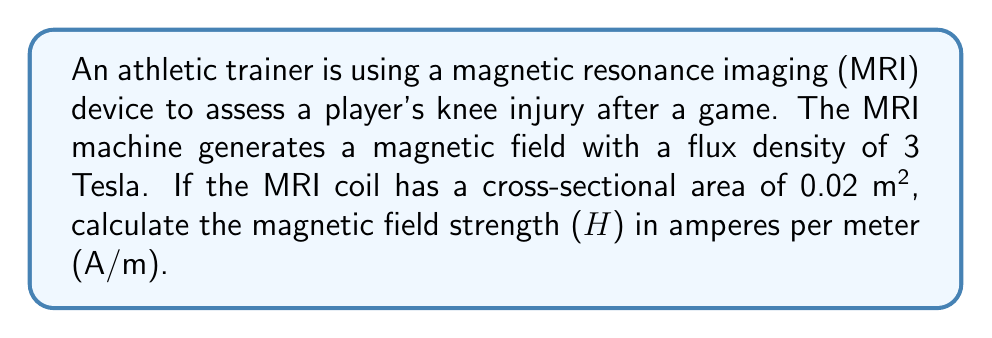Could you help me with this problem? To solve this problem, we'll follow these steps:

1. Recall the relationship between magnetic flux density (B), magnetic field strength (H), and permeability (μ):

   $$B = \mu H$$

2. In this case, we're dealing with an MRI machine, which typically uses air-core coils. For air, the permeability is approximately equal to the permeability of free space (μ₀):

   $$\mu \approx \mu_0 = 4\pi \times 10^{-7} \text{ H/m}$$

3. Rearrange the equation to solve for H:

   $$H = \frac{B}{\mu_0}$$

4. Substitute the given values:
   B = 3 T
   μ₀ = 4π × 10⁻⁷ H/m

5. Calculate H:

   $$H = \frac{3 \text{ T}}{4\pi \times 10^{-7} \text{ H/m}}$$

6. Simplify:

   $$H = \frac{3}{4\pi \times 10^{-7}} \text{ A/m}$$

   $$H = 2.39 \times 10^6 \text{ A/m}$$

Note: The cross-sectional area of the coil (0.02 m²) is not needed for this calculation, as the magnetic field strength is independent of the coil's area.
Answer: $2.39 \times 10^6 \text{ A/m}$ 